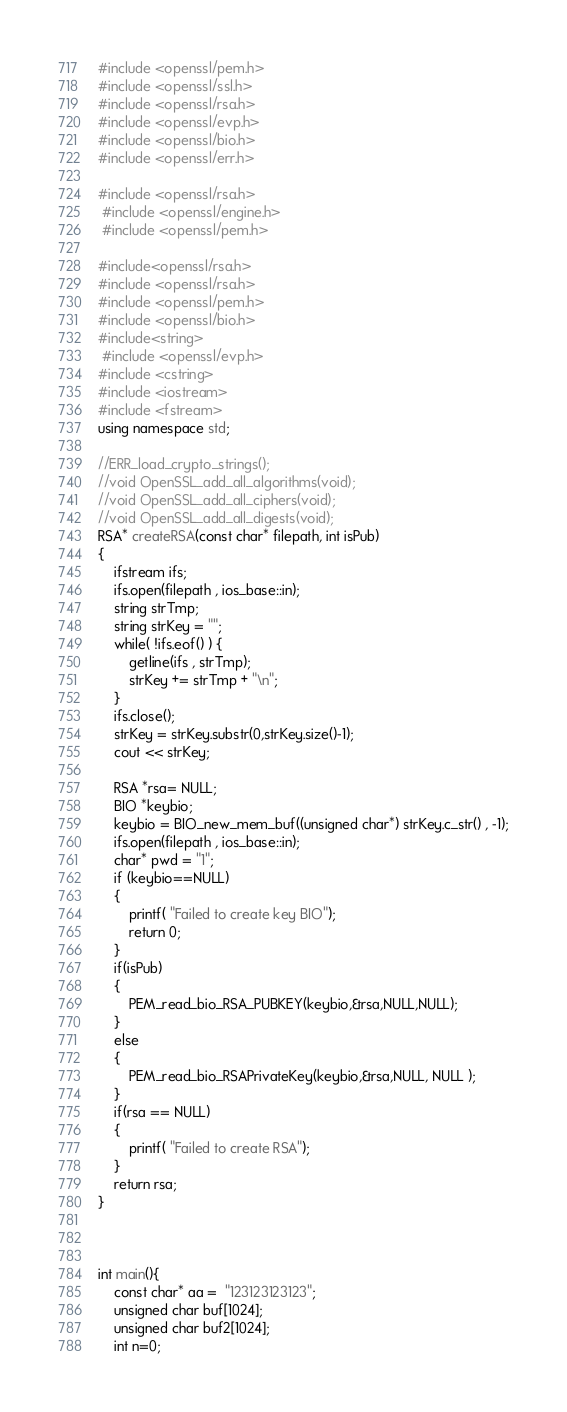<code> <loc_0><loc_0><loc_500><loc_500><_C++_>#include <openssl/pem.h>
#include <openssl/ssl.h>
#include <openssl/rsa.h>
#include <openssl/evp.h>
#include <openssl/bio.h>
#include <openssl/err.h>

#include <openssl/rsa.h>
 #include <openssl/engine.h>
 #include <openssl/pem.h>

#include<openssl/rsa.h>
#include <openssl/rsa.h>
#include <openssl/pem.h>
#include <openssl/bio.h>
#include<string>
 #include <openssl/evp.h>
#include <cstring>
#include <iostream>
#include <fstream>
using namespace std;

//ERR_load_crypto_strings();
//void OpenSSL_add_all_algorithms(void);
//void OpenSSL_add_all_ciphers(void);
//void OpenSSL_add_all_digests(void);
RSA* createRSA(const char* filepath, int isPub)
{
	ifstream ifs;
	ifs.open(filepath , ios_base::in);
	string strTmp;
	string strKey = "";
	while( !ifs.eof() ) {
		getline(ifs , strTmp);
		strKey += strTmp + "\n";
	}
	ifs.close();
	strKey = strKey.substr(0,strKey.size()-1);
	cout << strKey;

	RSA *rsa= NULL;
	BIO *keybio;
	keybio = BIO_new_mem_buf((unsigned char*) strKey.c_str() , -1);
	ifs.open(filepath , ios_base::in);
	char* pwd = "1";	
	if (keybio==NULL)
	{
		printf( "Failed to create key BIO");
		return 0;
	}
	if(isPub)
	{
		PEM_read_bio_RSA_PUBKEY(keybio,&rsa,NULL,NULL);
	}
	else
	{
		PEM_read_bio_RSAPrivateKey(keybio,&rsa,NULL, NULL );
	}
	if(rsa == NULL)
	{
		printf( "Failed to create RSA");
	}
	return rsa;
}



int main(){
	const char* aa =  "123123123123";
	unsigned char buf[1024];
	unsigned char buf2[1024];
	int n=0;</code> 